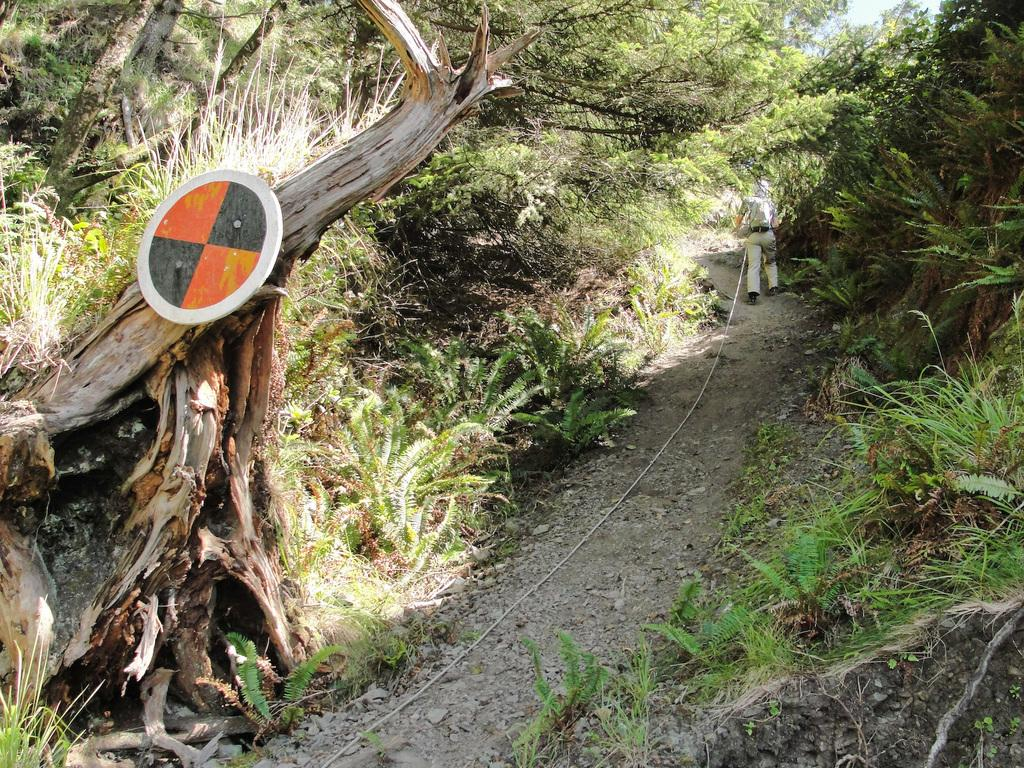What is the main subject of the image? There is a man in the image. What is the man wearing? The man is wearing a shirt and trousers. What is the man doing in the image? The man is walking. What type of natural environment can be seen in the image? There are trees visible in the image. What type of man-made structure can be seen in the image? There is a sign board in the image. What type of terrain is visible in the image? There is land visible in the image. What part of the natural environment is visible in the image? The sky is visible in the image. What type of boundary can be seen in the image? There is no boundary visible in the image. What type of joke is the man telling in the image? There is no indication that the man is telling a joke in the image. 